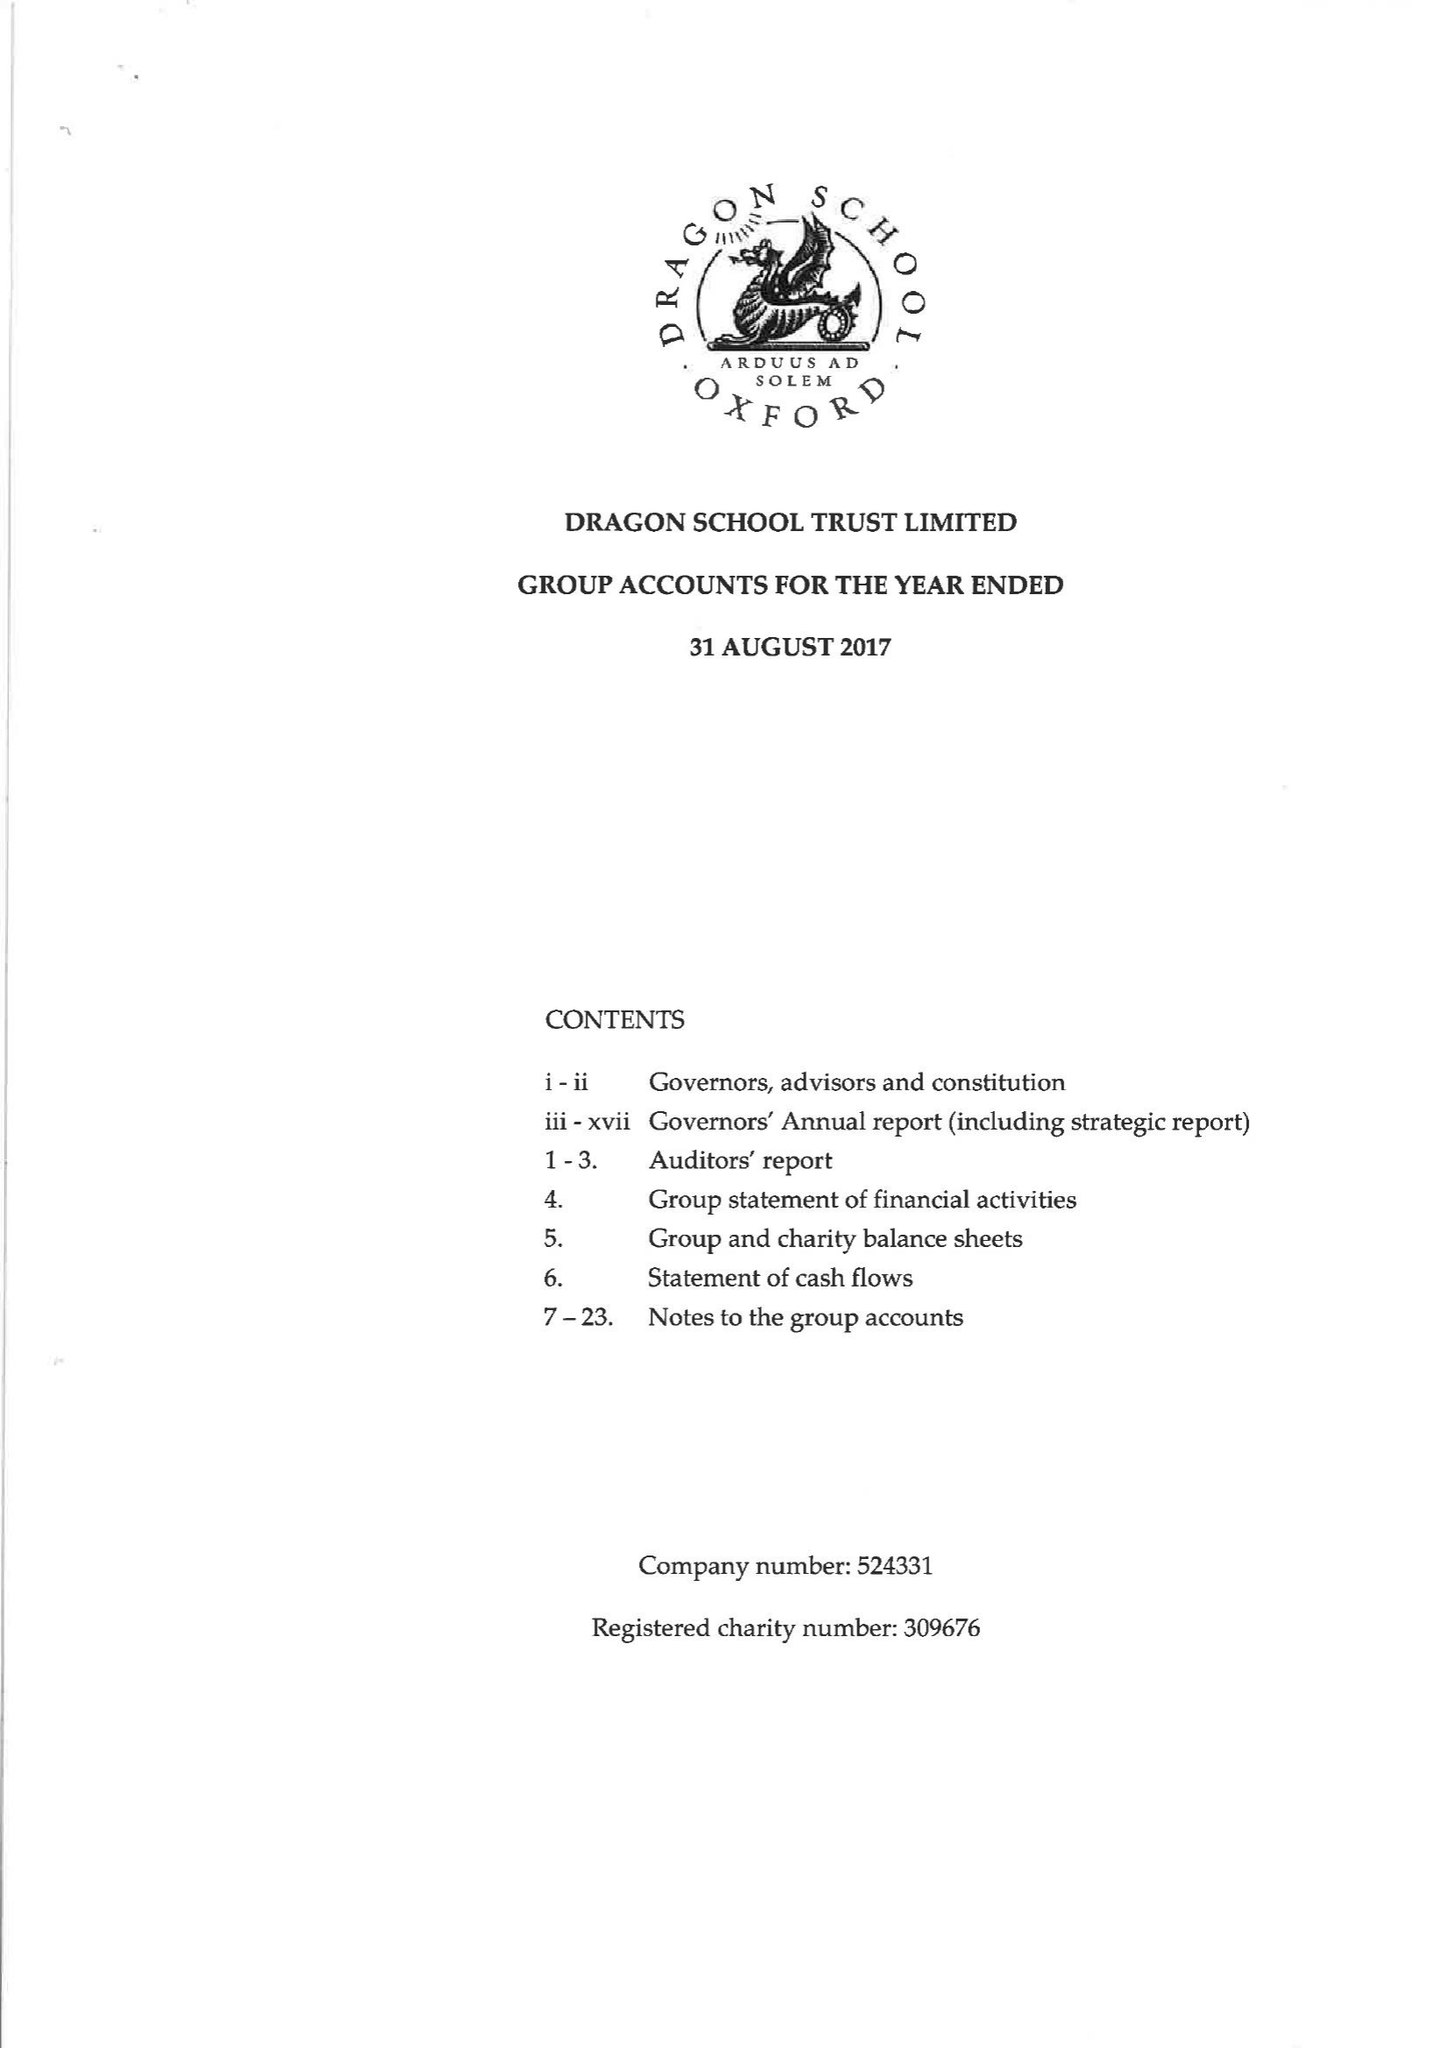What is the value for the address__street_line?
Answer the question using a single word or phrase. BARDWELL ROAD 